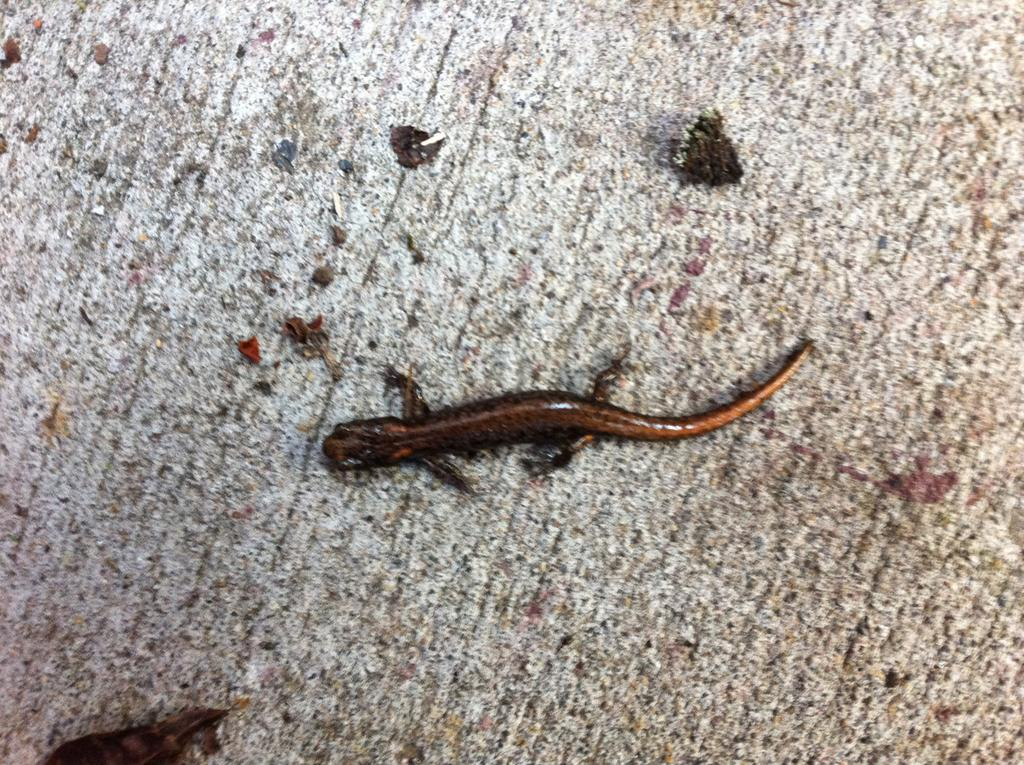What type of animal is present on a surface in the image? There is a reptile on a surface in the image. What type of liquid is being poured from the jar onto the stem in the image? There is no jar, stem, or liquid present in the image; it only features a reptile on a surface. 